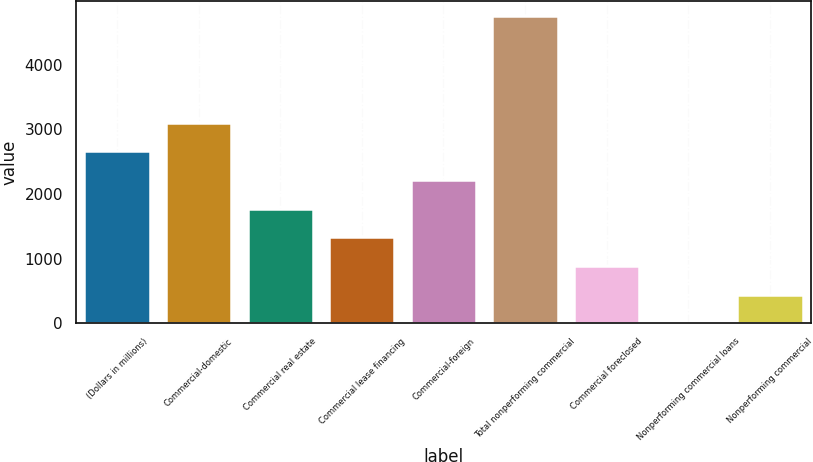Convert chart to OTSL. <chart><loc_0><loc_0><loc_500><loc_500><bar_chart><fcel>(Dollars in millions)<fcel>Commercial-domestic<fcel>Commercial real estate<fcel>Commercial lease financing<fcel>Commercial-foreign<fcel>Total nonperforming commercial<fcel>Commercial foreclosed<fcel>Nonperforming commercial loans<fcel>Nonperforming commercial<nl><fcel>2659.16<fcel>3101.86<fcel>1773.76<fcel>1331.06<fcel>2216.46<fcel>4746.7<fcel>888.36<fcel>2.96<fcel>445.66<nl></chart> 